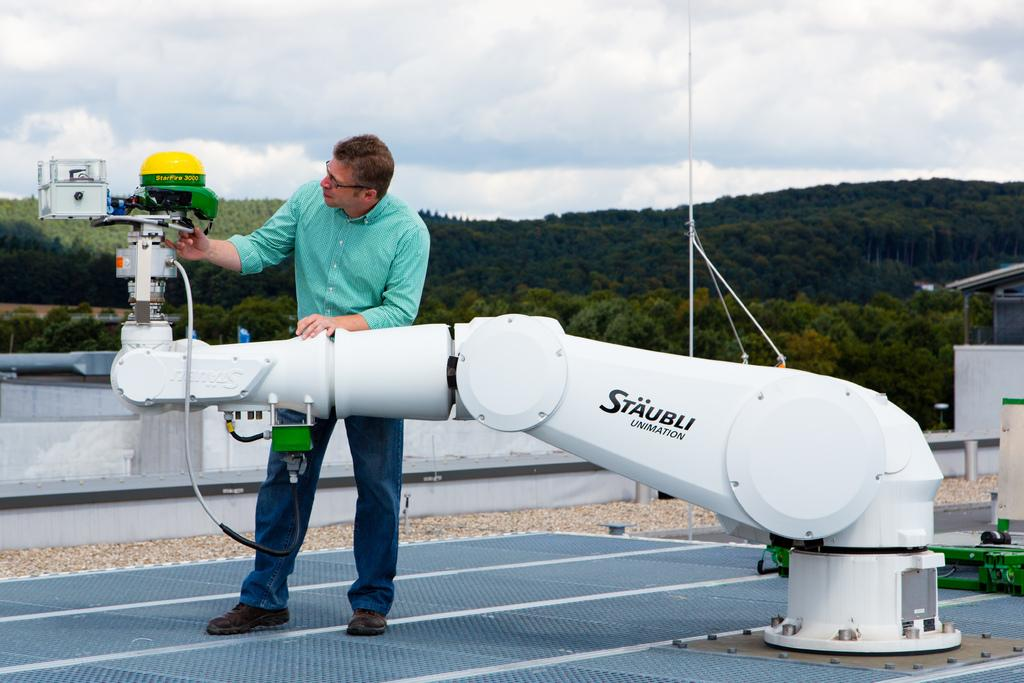What type of equipment is in the image? There is an electric equipment in the image. Who is present in the image? A man is standing in the image. What is the man wearing? The man is wearing a green color shirt. What can be seen in the background of the image? There are trees in the background of the image. What is visible at the top of the image? The sky is visible at the top of the image, and clouds are present in the sky. Can you tell me how many gooses are standing next to the man in the image? There are no gooses present in the image; only the man and electric equipment are visible. What type of tool is the man using to fix the electric equipment in the image? There is no tool visible in the image, and the man is not shown fixing the equipment. 